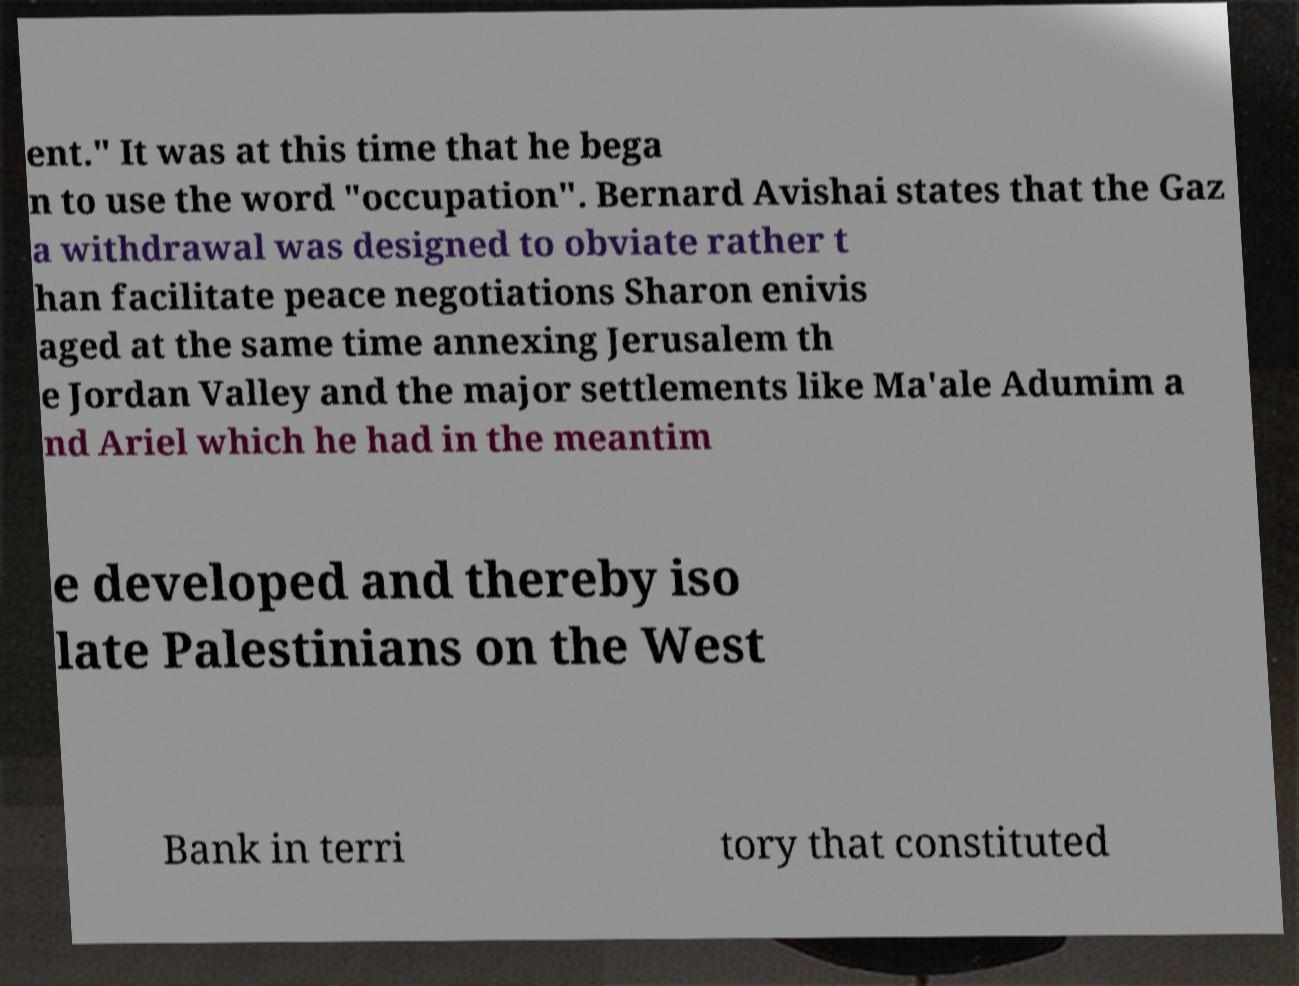For documentation purposes, I need the text within this image transcribed. Could you provide that? ent.″ It was at this time that he bega n to use the word "occupation". Bernard Avishai states that the Gaz a withdrawal was designed to obviate rather t han facilitate peace negotiations Sharon enivis aged at the same time annexing Jerusalem th e Jordan Valley and the major settlements like Ma'ale Adumim a nd Ariel which he had in the meantim e developed and thereby iso late Palestinians on the West Bank in terri tory that constituted 